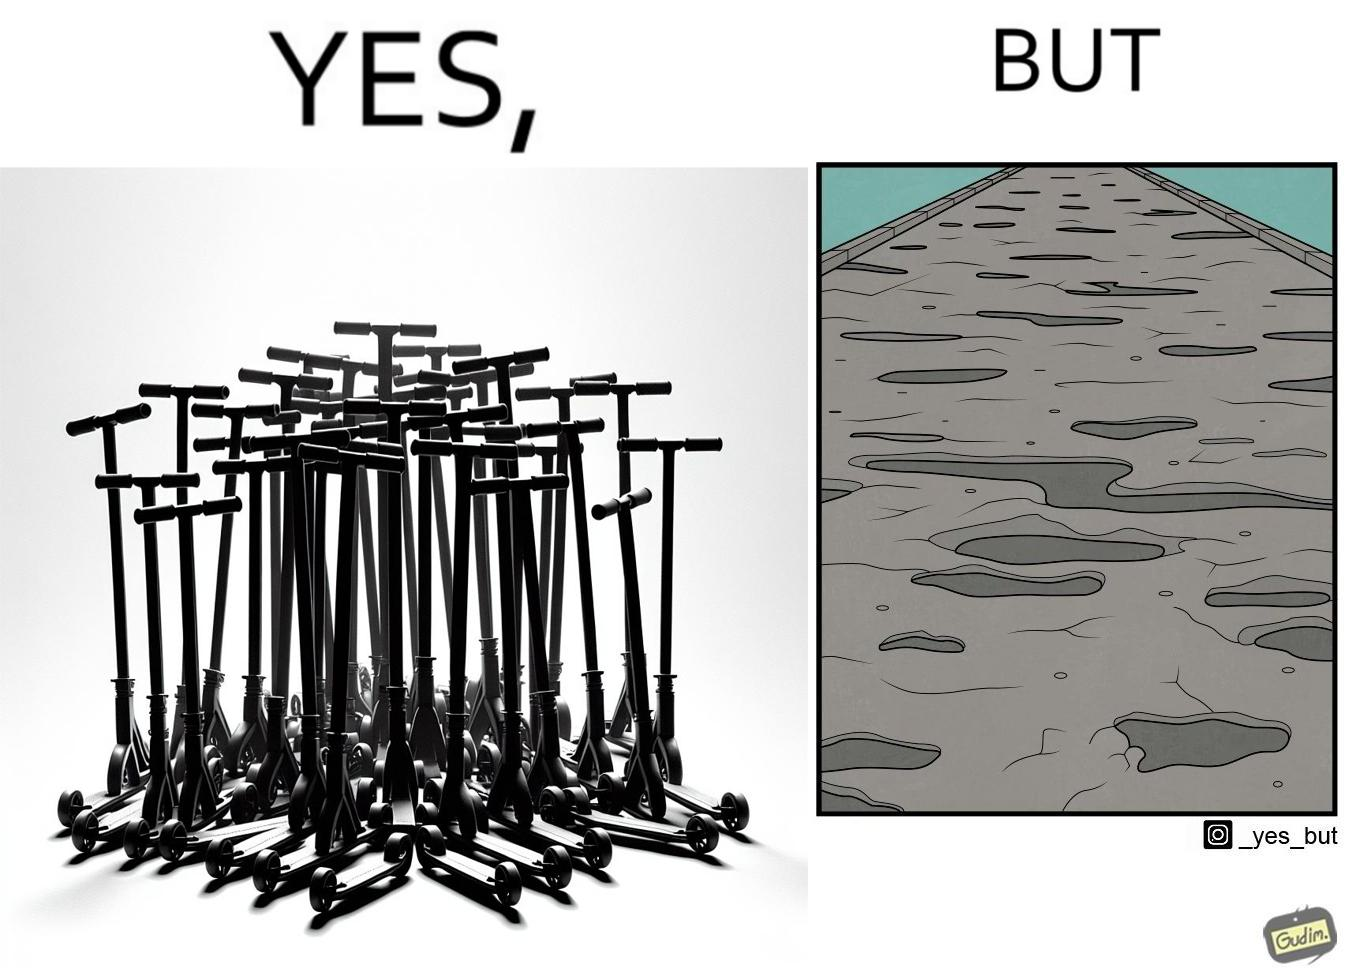Is there satirical content in this image? Yes, this image is satirical. 